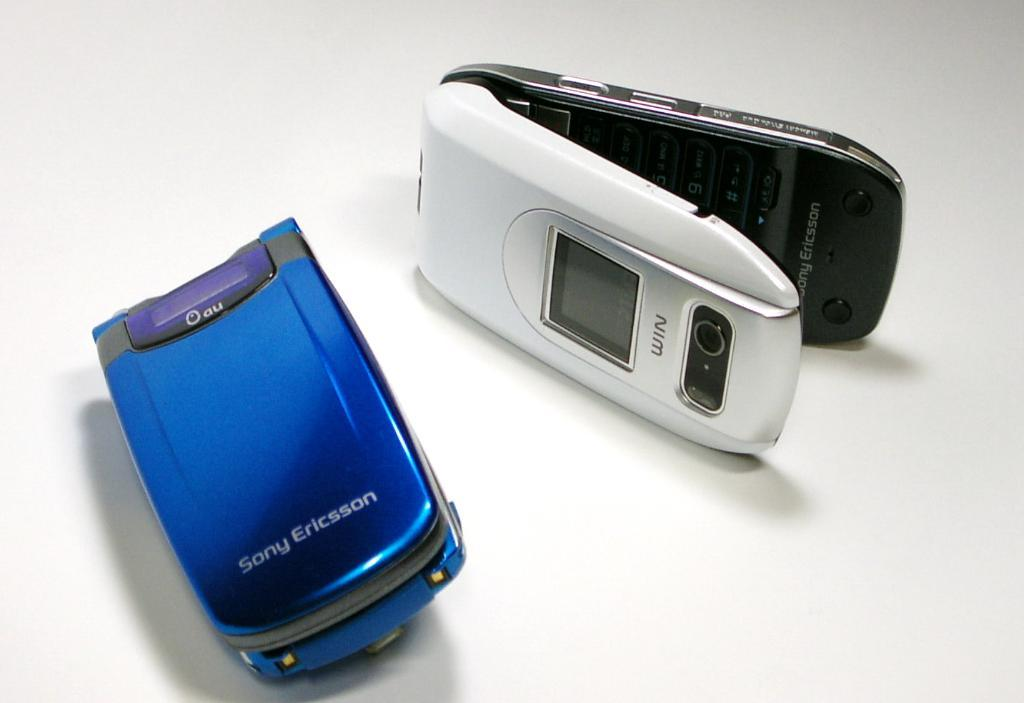<image>
Provide a brief description of the given image. A blue flip phone from Sony Ericsson and a white as well. 